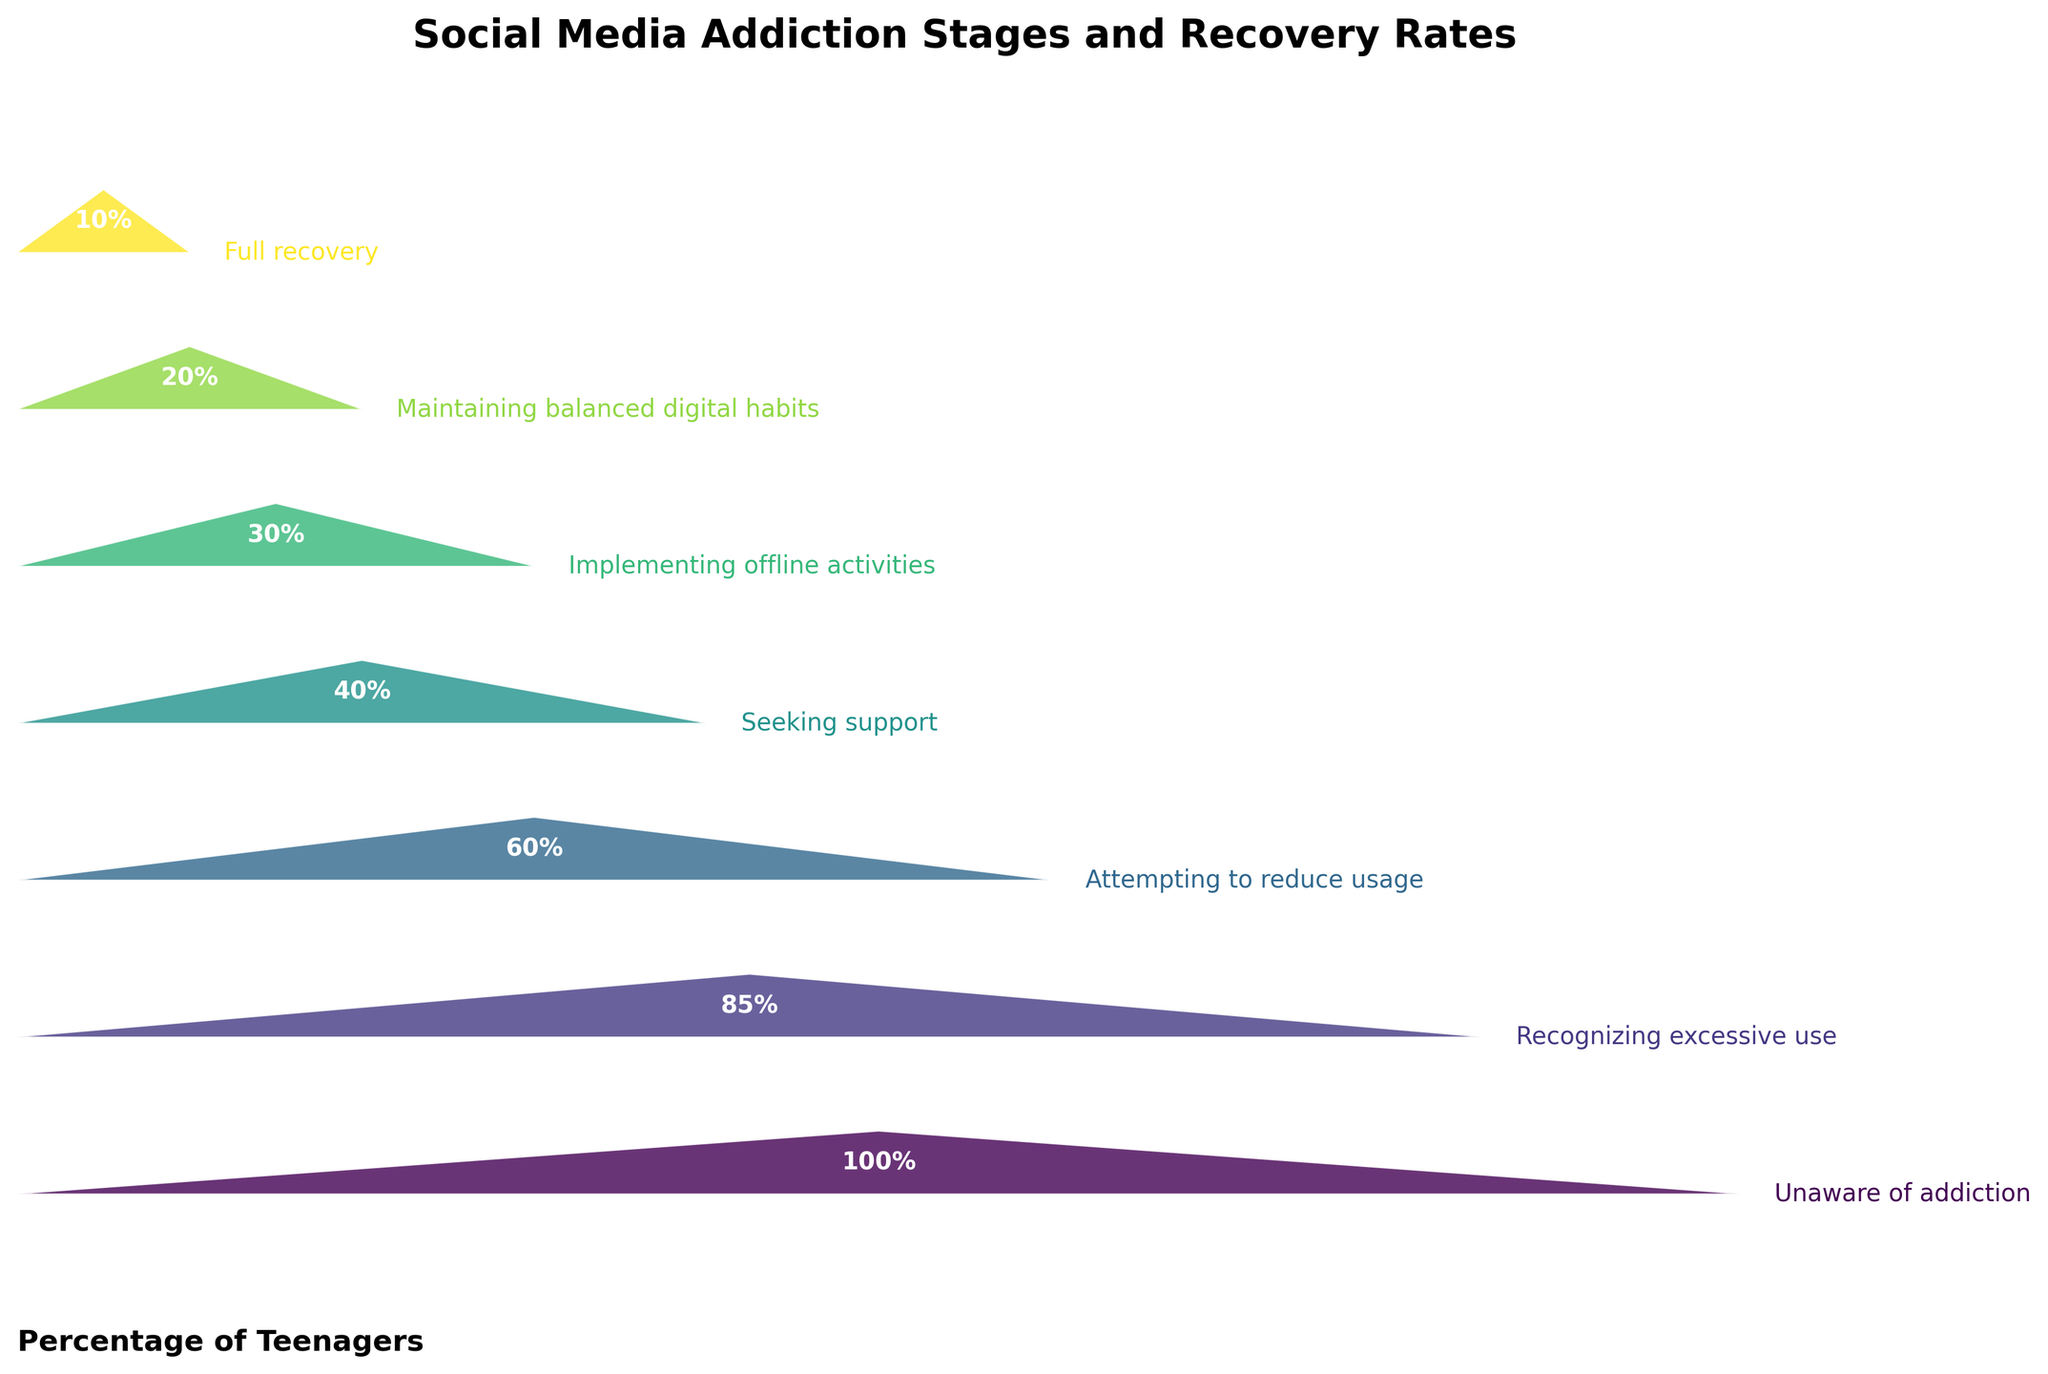Which stage has the highest percentage of teenagers currently? The stage with the largest percentage according to the bars in the funnel chart is "Unaware of addiction" at the top.
Answer: 100% Which stage immediately follows "Attempting to reduce usage"? The next stage listed in the funnel chart right after "Attempting to reduce usage" is "Seeking support".
Answer: Seeking support By how much does the percentage decrease from "Recognizing excessive use" to "Attempting to reduce usage"? The percentage for "Recognizing excessive use" is 85%, and for "Attempting to reduce usage" is 60%. The decrease is 85% - 60% = 25%.
Answer: 25% At which stage are 30% of teenagers? The stage at which 30% of teenagers are is "Implementing offline activities", as indicated in the funnel chart.
Answer: Implementing offline activities How many stages are represented in the funnel chart? By counting all stages listed in the funnel chart, we find there are 7 stages.
Answer: 7 Identify the stage with the lowest recovery rate. The last stage in the funnel chart, which has the smallest percentage, is "Full recovery" with 10%.
Answer: Full recovery What is the average percentage reduction per stage from "Unaware of addiction" to "Full recovery"? Calculating the percentage decreases between each consecutive stage: (100-85) + (85-60) + (60-40) + (40-30) + (30-20) + (20-10) = 15 + 25 + 20 + 10 + 10 + 10 = 90%. The average reduction for 6 transitions: 90% / 6 = 15%.
Answer: 15% Is the percentage of teenagers maintaining balanced digital habits closer to the percentage attempting to reduce usage or implementing offline activities? The percentage of teenagers maintaining balanced digital habits is 20%. Attempting to reduce usage is 60%, which is 40% difference. Implementing offline activities is 30%, which is 10% difference. Therefore, it is closer to implementing offline activities.
Answer: Closer to implementing offline activities 